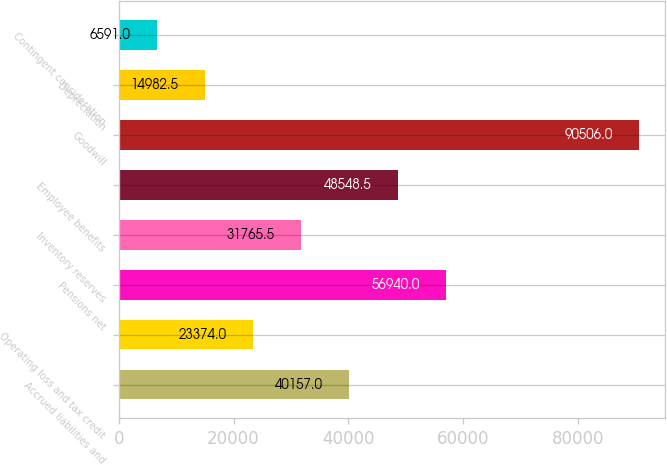Convert chart to OTSL. <chart><loc_0><loc_0><loc_500><loc_500><bar_chart><fcel>Accrued liabilities and<fcel>Operating loss and tax credit<fcel>Pensions net<fcel>Inventory reserves<fcel>Employee benefits<fcel>Goodwill<fcel>Depreciation<fcel>Contingent consideration<nl><fcel>40157<fcel>23374<fcel>56940<fcel>31765.5<fcel>48548.5<fcel>90506<fcel>14982.5<fcel>6591<nl></chart> 